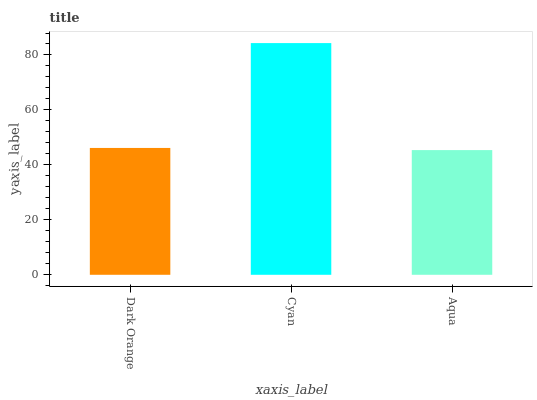Is Aqua the minimum?
Answer yes or no. Yes. Is Cyan the maximum?
Answer yes or no. Yes. Is Cyan the minimum?
Answer yes or no. No. Is Aqua the maximum?
Answer yes or no. No. Is Cyan greater than Aqua?
Answer yes or no. Yes. Is Aqua less than Cyan?
Answer yes or no. Yes. Is Aqua greater than Cyan?
Answer yes or no. No. Is Cyan less than Aqua?
Answer yes or no. No. Is Dark Orange the high median?
Answer yes or no. Yes. Is Dark Orange the low median?
Answer yes or no. Yes. Is Aqua the high median?
Answer yes or no. No. Is Cyan the low median?
Answer yes or no. No. 